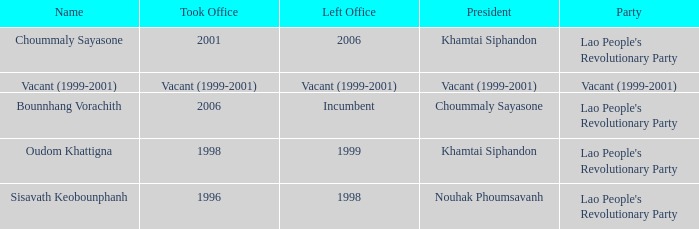What is Party, when Took Office is 1998? Lao People's Revolutionary Party. Parse the table in full. {'header': ['Name', 'Took Office', 'Left Office', 'President', 'Party'], 'rows': [['Choummaly Sayasone', '2001', '2006', 'Khamtai Siphandon', "Lao People's Revolutionary Party"], ['Vacant (1999-2001)', 'Vacant (1999-2001)', 'Vacant (1999-2001)', 'Vacant (1999-2001)', 'Vacant (1999-2001)'], ['Bounnhang Vorachith', '2006', 'Incumbent', 'Choummaly Sayasone', "Lao People's Revolutionary Party"], ['Oudom Khattigna', '1998', '1999', 'Khamtai Siphandon', "Lao People's Revolutionary Party"], ['Sisavath Keobounphanh', '1996', '1998', 'Nouhak Phoumsavanh', "Lao People's Revolutionary Party"]]} 